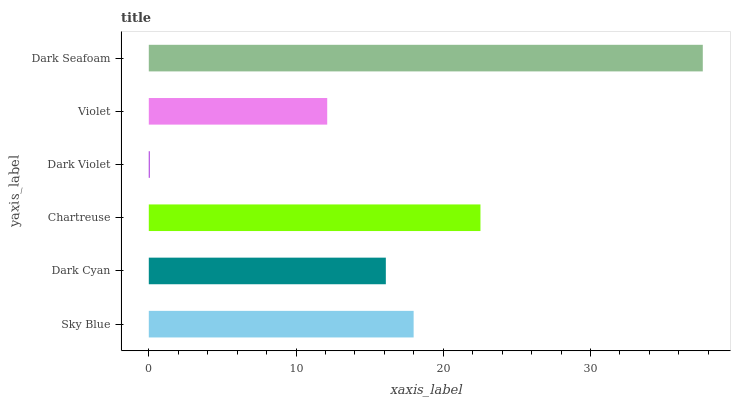Is Dark Violet the minimum?
Answer yes or no. Yes. Is Dark Seafoam the maximum?
Answer yes or no. Yes. Is Dark Cyan the minimum?
Answer yes or no. No. Is Dark Cyan the maximum?
Answer yes or no. No. Is Sky Blue greater than Dark Cyan?
Answer yes or no. Yes. Is Dark Cyan less than Sky Blue?
Answer yes or no. Yes. Is Dark Cyan greater than Sky Blue?
Answer yes or no. No. Is Sky Blue less than Dark Cyan?
Answer yes or no. No. Is Sky Blue the high median?
Answer yes or no. Yes. Is Dark Cyan the low median?
Answer yes or no. Yes. Is Chartreuse the high median?
Answer yes or no. No. Is Dark Seafoam the low median?
Answer yes or no. No. 